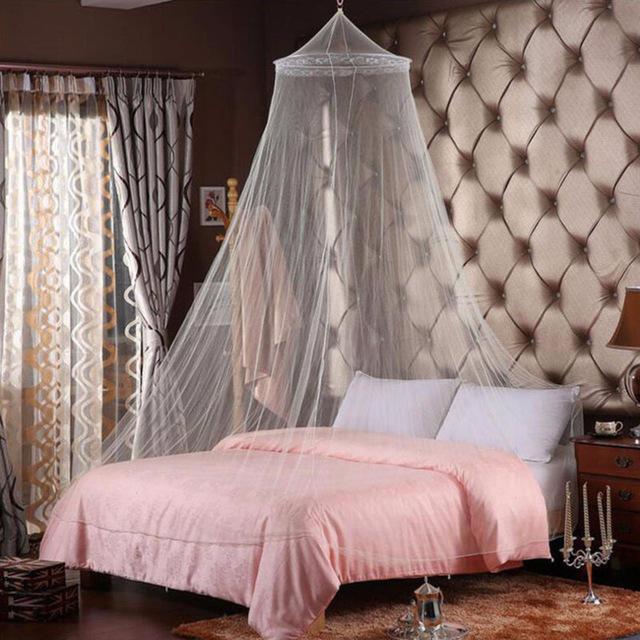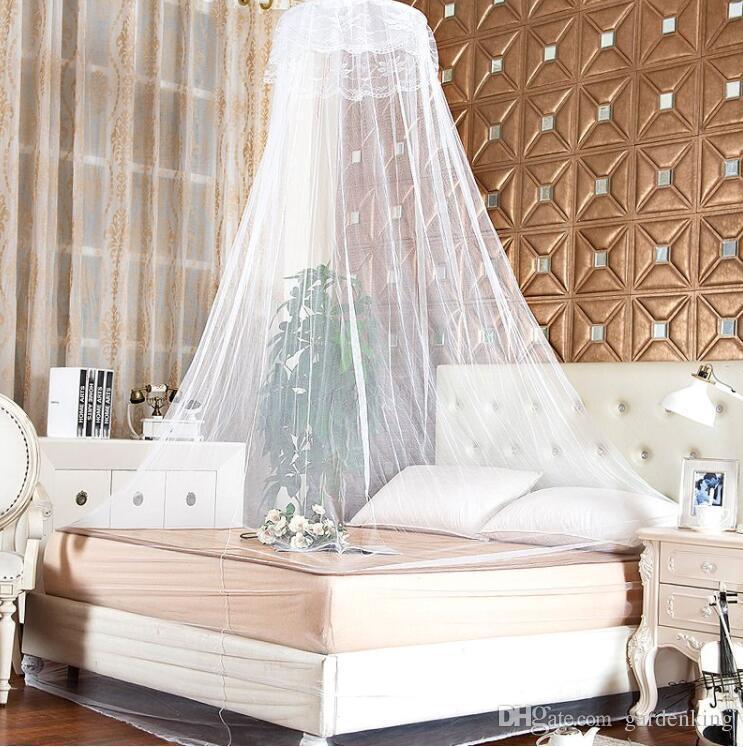The first image is the image on the left, the second image is the image on the right. Given the left and right images, does the statement "There are two white pillows in the image to the right." hold true? Answer yes or no. Yes. The first image is the image on the left, the second image is the image on the right. Considering the images on both sides, is "Some of the sheets are blue." valid? Answer yes or no. No. 